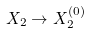Convert formula to latex. <formula><loc_0><loc_0><loc_500><loc_500>X _ { 2 } \rightarrow X _ { 2 } ^ { ( 0 ) }</formula> 